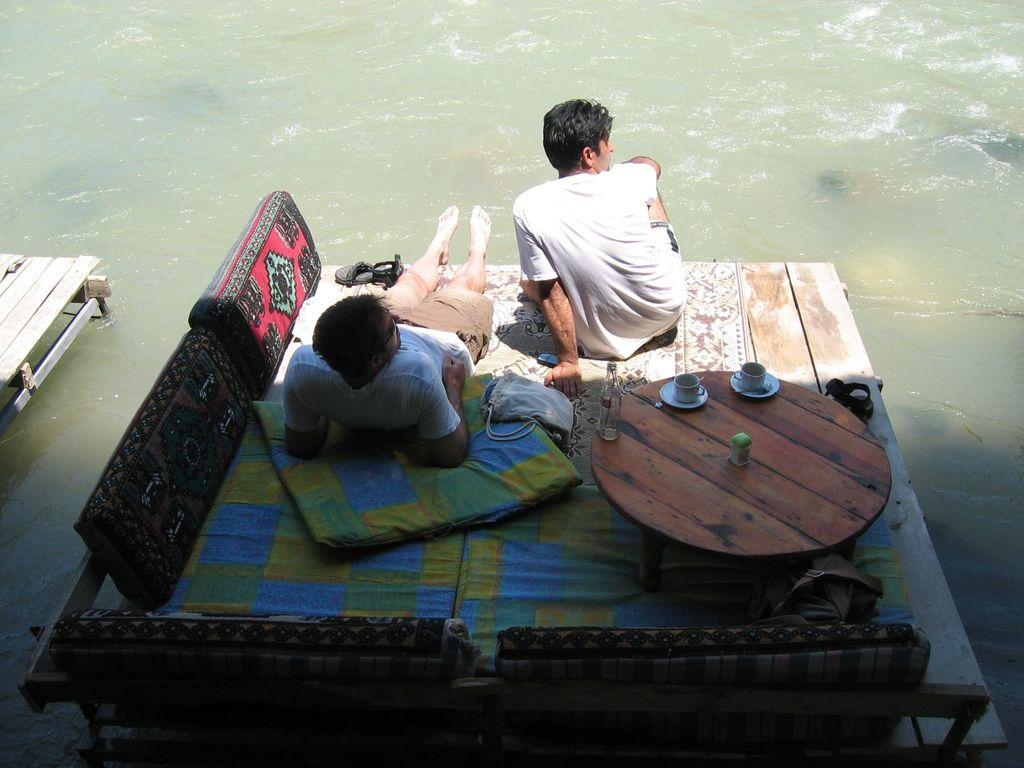What are the two men in the image doing? There is a man laying on a wooden plank and another man sitting on a wooden plank, both observing the water. What is the surface they are on made of? The wooden plank is the surface they are on. What items can be seen on the table in the image? There are pillows and tea cups on the table. Are there any slaves visible in the image? There is no mention of slaves in the image, and no such figures are present. Can you see any pigs or lettuce in the image? There are no pigs or lettuce present in the image. 